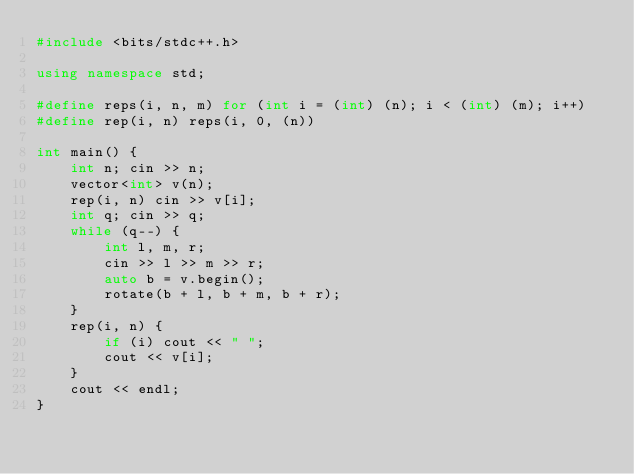<code> <loc_0><loc_0><loc_500><loc_500><_C++_>#include <bits/stdc++.h>

using namespace std;

#define reps(i, n, m) for (int i = (int) (n); i < (int) (m); i++)
#define rep(i, n) reps(i, 0, (n))

int main() {
    int n; cin >> n;
    vector<int> v(n);
    rep(i, n) cin >> v[i];
    int q; cin >> q;
    while (q--) {
        int l, m, r;
        cin >> l >> m >> r;
        auto b = v.begin();
        rotate(b + l, b + m, b + r);
    }
    rep(i, n) {
        if (i) cout << " ";
        cout << v[i];
    }
    cout << endl;
}
</code> 